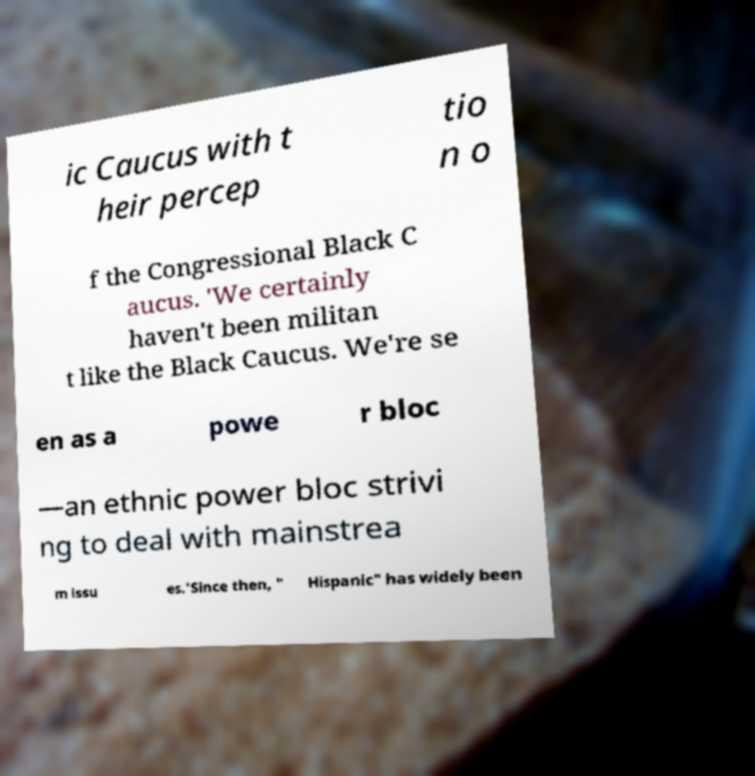Can you accurately transcribe the text from the provided image for me? ic Caucus with t heir percep tio n o f the Congressional Black C aucus. 'We certainly haven't been militan t like the Black Caucus. We're se en as a powe r bloc —an ethnic power bloc strivi ng to deal with mainstrea m issu es.'Since then, " Hispanic" has widely been 